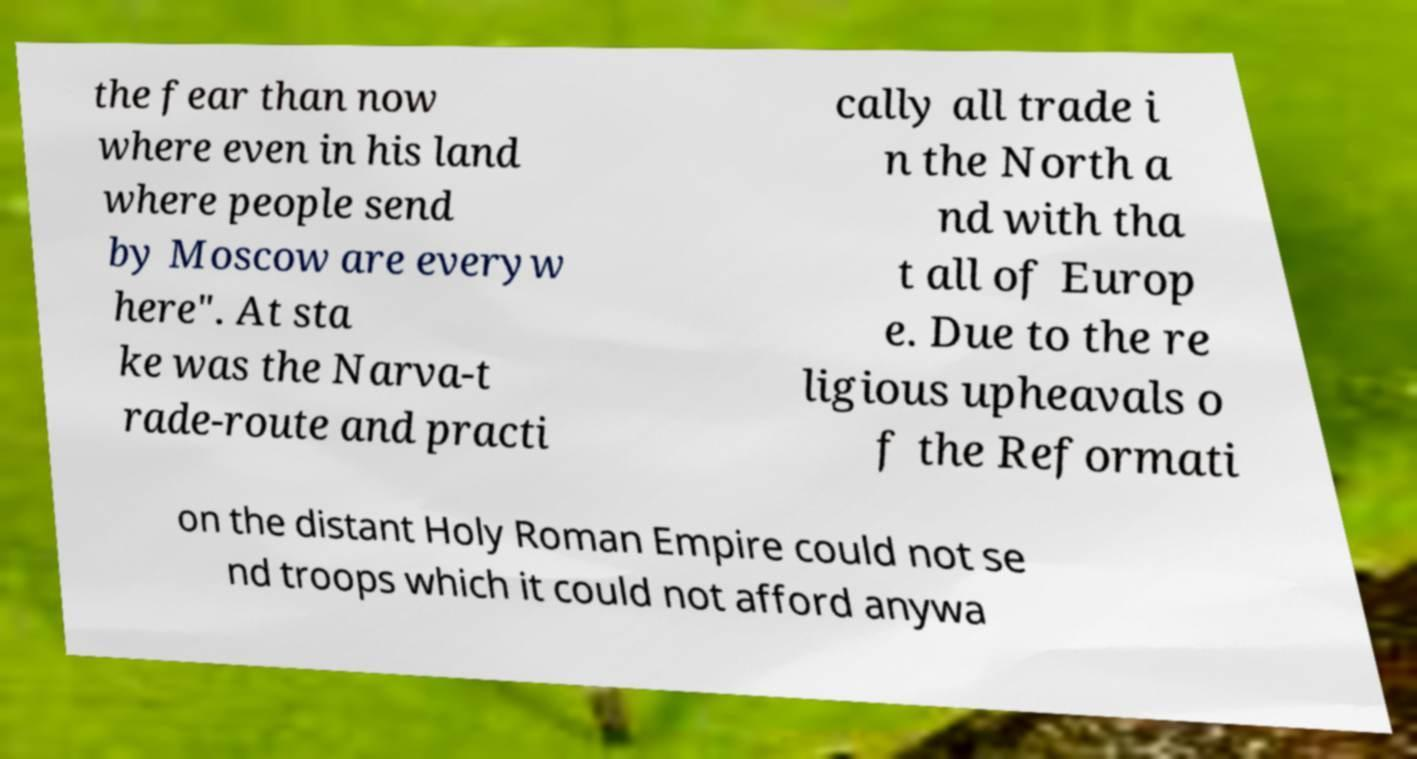What messages or text are displayed in this image? I need them in a readable, typed format. the fear than now where even in his land where people send by Moscow are everyw here". At sta ke was the Narva-t rade-route and practi cally all trade i n the North a nd with tha t all of Europ e. Due to the re ligious upheavals o f the Reformati on the distant Holy Roman Empire could not se nd troops which it could not afford anywa 